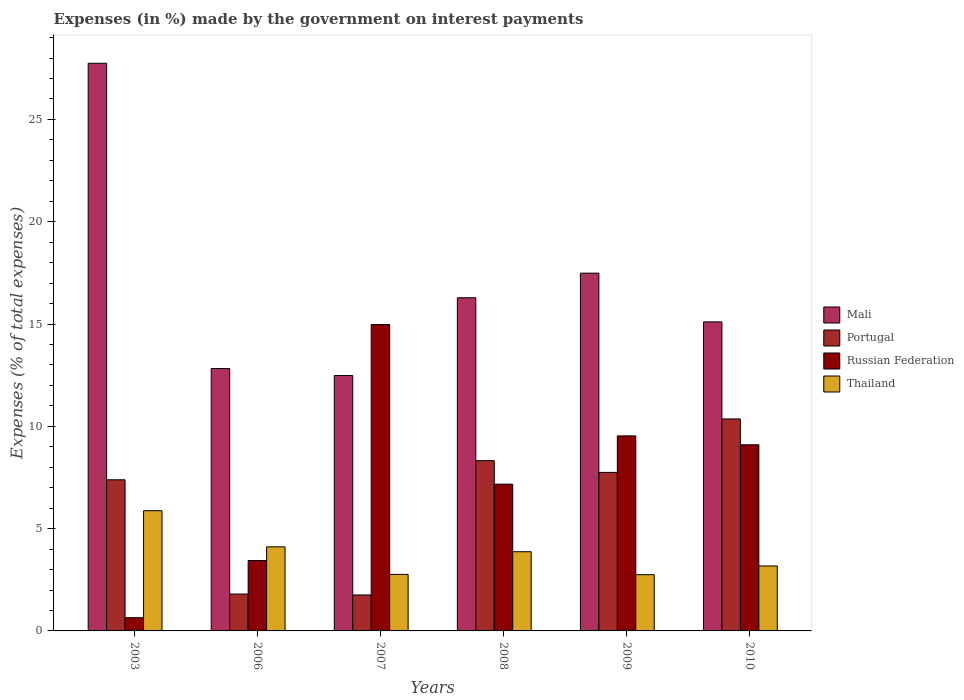How many different coloured bars are there?
Your answer should be compact. 4. How many groups of bars are there?
Your answer should be very brief. 6. Are the number of bars per tick equal to the number of legend labels?
Ensure brevity in your answer.  Yes. Are the number of bars on each tick of the X-axis equal?
Your response must be concise. Yes. How many bars are there on the 4th tick from the left?
Provide a succinct answer. 4. In how many cases, is the number of bars for a given year not equal to the number of legend labels?
Offer a terse response. 0. What is the percentage of expenses made by the government on interest payments in Mali in 2010?
Provide a short and direct response. 15.11. Across all years, what is the maximum percentage of expenses made by the government on interest payments in Thailand?
Make the answer very short. 5.88. Across all years, what is the minimum percentage of expenses made by the government on interest payments in Thailand?
Your answer should be very brief. 2.75. In which year was the percentage of expenses made by the government on interest payments in Portugal maximum?
Provide a short and direct response. 2010. In which year was the percentage of expenses made by the government on interest payments in Portugal minimum?
Offer a very short reply. 2007. What is the total percentage of expenses made by the government on interest payments in Thailand in the graph?
Your answer should be very brief. 22.54. What is the difference between the percentage of expenses made by the government on interest payments in Mali in 2008 and that in 2009?
Give a very brief answer. -1.2. What is the difference between the percentage of expenses made by the government on interest payments in Russian Federation in 2007 and the percentage of expenses made by the government on interest payments in Portugal in 2006?
Make the answer very short. 13.17. What is the average percentage of expenses made by the government on interest payments in Portugal per year?
Provide a short and direct response. 6.23. In the year 2003, what is the difference between the percentage of expenses made by the government on interest payments in Thailand and percentage of expenses made by the government on interest payments in Portugal?
Offer a terse response. -1.51. In how many years, is the percentage of expenses made by the government on interest payments in Mali greater than 5 %?
Make the answer very short. 6. What is the ratio of the percentage of expenses made by the government on interest payments in Thailand in 2006 to that in 2009?
Make the answer very short. 1.5. What is the difference between the highest and the second highest percentage of expenses made by the government on interest payments in Mali?
Your answer should be very brief. 10.26. What is the difference between the highest and the lowest percentage of expenses made by the government on interest payments in Thailand?
Offer a terse response. 3.13. In how many years, is the percentage of expenses made by the government on interest payments in Russian Federation greater than the average percentage of expenses made by the government on interest payments in Russian Federation taken over all years?
Offer a terse response. 3. Is the sum of the percentage of expenses made by the government on interest payments in Thailand in 2007 and 2010 greater than the maximum percentage of expenses made by the government on interest payments in Mali across all years?
Offer a terse response. No. What does the 4th bar from the left in 2007 represents?
Your answer should be very brief. Thailand. What does the 2nd bar from the right in 2008 represents?
Your answer should be very brief. Russian Federation. Is it the case that in every year, the sum of the percentage of expenses made by the government on interest payments in Portugal and percentage of expenses made by the government on interest payments in Thailand is greater than the percentage of expenses made by the government on interest payments in Russian Federation?
Keep it short and to the point. No. How many bars are there?
Offer a terse response. 24. Are all the bars in the graph horizontal?
Your answer should be very brief. No. How many years are there in the graph?
Give a very brief answer. 6. What is the difference between two consecutive major ticks on the Y-axis?
Offer a terse response. 5. Does the graph contain any zero values?
Your answer should be very brief. No. How are the legend labels stacked?
Offer a terse response. Vertical. What is the title of the graph?
Offer a very short reply. Expenses (in %) made by the government on interest payments. Does "Uzbekistan" appear as one of the legend labels in the graph?
Your answer should be compact. No. What is the label or title of the X-axis?
Provide a succinct answer. Years. What is the label or title of the Y-axis?
Ensure brevity in your answer.  Expenses (% of total expenses). What is the Expenses (% of total expenses) of Mali in 2003?
Your response must be concise. 27.75. What is the Expenses (% of total expenses) in Portugal in 2003?
Offer a terse response. 7.39. What is the Expenses (% of total expenses) in Russian Federation in 2003?
Provide a succinct answer. 0.65. What is the Expenses (% of total expenses) of Thailand in 2003?
Offer a terse response. 5.88. What is the Expenses (% of total expenses) in Mali in 2006?
Your answer should be very brief. 12.82. What is the Expenses (% of total expenses) in Portugal in 2006?
Offer a very short reply. 1.8. What is the Expenses (% of total expenses) of Russian Federation in 2006?
Offer a terse response. 3.44. What is the Expenses (% of total expenses) in Thailand in 2006?
Keep it short and to the point. 4.11. What is the Expenses (% of total expenses) in Mali in 2007?
Provide a short and direct response. 12.49. What is the Expenses (% of total expenses) of Portugal in 2007?
Make the answer very short. 1.76. What is the Expenses (% of total expenses) of Russian Federation in 2007?
Offer a terse response. 14.98. What is the Expenses (% of total expenses) of Thailand in 2007?
Your answer should be compact. 2.76. What is the Expenses (% of total expenses) of Mali in 2008?
Offer a terse response. 16.28. What is the Expenses (% of total expenses) in Portugal in 2008?
Offer a terse response. 8.32. What is the Expenses (% of total expenses) in Russian Federation in 2008?
Give a very brief answer. 7.17. What is the Expenses (% of total expenses) in Thailand in 2008?
Your response must be concise. 3.87. What is the Expenses (% of total expenses) in Mali in 2009?
Give a very brief answer. 17.49. What is the Expenses (% of total expenses) in Portugal in 2009?
Your answer should be compact. 7.75. What is the Expenses (% of total expenses) in Russian Federation in 2009?
Keep it short and to the point. 9.53. What is the Expenses (% of total expenses) of Thailand in 2009?
Keep it short and to the point. 2.75. What is the Expenses (% of total expenses) in Mali in 2010?
Keep it short and to the point. 15.11. What is the Expenses (% of total expenses) in Portugal in 2010?
Offer a terse response. 10.36. What is the Expenses (% of total expenses) of Russian Federation in 2010?
Keep it short and to the point. 9.1. What is the Expenses (% of total expenses) in Thailand in 2010?
Offer a terse response. 3.18. Across all years, what is the maximum Expenses (% of total expenses) in Mali?
Ensure brevity in your answer.  27.75. Across all years, what is the maximum Expenses (% of total expenses) of Portugal?
Keep it short and to the point. 10.36. Across all years, what is the maximum Expenses (% of total expenses) of Russian Federation?
Offer a very short reply. 14.98. Across all years, what is the maximum Expenses (% of total expenses) in Thailand?
Keep it short and to the point. 5.88. Across all years, what is the minimum Expenses (% of total expenses) of Mali?
Keep it short and to the point. 12.49. Across all years, what is the minimum Expenses (% of total expenses) in Portugal?
Your response must be concise. 1.76. Across all years, what is the minimum Expenses (% of total expenses) of Russian Federation?
Your answer should be compact. 0.65. Across all years, what is the minimum Expenses (% of total expenses) of Thailand?
Keep it short and to the point. 2.75. What is the total Expenses (% of total expenses) in Mali in the graph?
Make the answer very short. 101.93. What is the total Expenses (% of total expenses) in Portugal in the graph?
Provide a short and direct response. 37.38. What is the total Expenses (% of total expenses) in Russian Federation in the graph?
Offer a terse response. 44.86. What is the total Expenses (% of total expenses) of Thailand in the graph?
Ensure brevity in your answer.  22.54. What is the difference between the Expenses (% of total expenses) in Mali in 2003 and that in 2006?
Provide a short and direct response. 14.92. What is the difference between the Expenses (% of total expenses) in Portugal in 2003 and that in 2006?
Make the answer very short. 5.58. What is the difference between the Expenses (% of total expenses) in Russian Federation in 2003 and that in 2006?
Your answer should be compact. -2.8. What is the difference between the Expenses (% of total expenses) of Thailand in 2003 and that in 2006?
Your answer should be very brief. 1.77. What is the difference between the Expenses (% of total expenses) of Mali in 2003 and that in 2007?
Your answer should be very brief. 15.26. What is the difference between the Expenses (% of total expenses) in Portugal in 2003 and that in 2007?
Ensure brevity in your answer.  5.63. What is the difference between the Expenses (% of total expenses) in Russian Federation in 2003 and that in 2007?
Keep it short and to the point. -14.33. What is the difference between the Expenses (% of total expenses) in Thailand in 2003 and that in 2007?
Your answer should be very brief. 3.11. What is the difference between the Expenses (% of total expenses) in Mali in 2003 and that in 2008?
Offer a very short reply. 11.46. What is the difference between the Expenses (% of total expenses) of Portugal in 2003 and that in 2008?
Your answer should be very brief. -0.93. What is the difference between the Expenses (% of total expenses) of Russian Federation in 2003 and that in 2008?
Offer a terse response. -6.53. What is the difference between the Expenses (% of total expenses) in Thailand in 2003 and that in 2008?
Offer a very short reply. 2. What is the difference between the Expenses (% of total expenses) in Mali in 2003 and that in 2009?
Your answer should be very brief. 10.26. What is the difference between the Expenses (% of total expenses) of Portugal in 2003 and that in 2009?
Provide a succinct answer. -0.36. What is the difference between the Expenses (% of total expenses) of Russian Federation in 2003 and that in 2009?
Your answer should be very brief. -8.89. What is the difference between the Expenses (% of total expenses) in Thailand in 2003 and that in 2009?
Ensure brevity in your answer.  3.13. What is the difference between the Expenses (% of total expenses) of Mali in 2003 and that in 2010?
Your response must be concise. 12.64. What is the difference between the Expenses (% of total expenses) in Portugal in 2003 and that in 2010?
Provide a succinct answer. -2.97. What is the difference between the Expenses (% of total expenses) in Russian Federation in 2003 and that in 2010?
Your answer should be compact. -8.45. What is the difference between the Expenses (% of total expenses) in Thailand in 2003 and that in 2010?
Provide a succinct answer. 2.7. What is the difference between the Expenses (% of total expenses) in Mali in 2006 and that in 2007?
Your answer should be compact. 0.34. What is the difference between the Expenses (% of total expenses) in Portugal in 2006 and that in 2007?
Ensure brevity in your answer.  0.04. What is the difference between the Expenses (% of total expenses) of Russian Federation in 2006 and that in 2007?
Ensure brevity in your answer.  -11.54. What is the difference between the Expenses (% of total expenses) in Thailand in 2006 and that in 2007?
Provide a succinct answer. 1.35. What is the difference between the Expenses (% of total expenses) of Mali in 2006 and that in 2008?
Offer a terse response. -3.46. What is the difference between the Expenses (% of total expenses) in Portugal in 2006 and that in 2008?
Your answer should be very brief. -6.52. What is the difference between the Expenses (% of total expenses) of Russian Federation in 2006 and that in 2008?
Keep it short and to the point. -3.73. What is the difference between the Expenses (% of total expenses) in Thailand in 2006 and that in 2008?
Your answer should be very brief. 0.24. What is the difference between the Expenses (% of total expenses) in Mali in 2006 and that in 2009?
Provide a succinct answer. -4.66. What is the difference between the Expenses (% of total expenses) in Portugal in 2006 and that in 2009?
Offer a very short reply. -5.95. What is the difference between the Expenses (% of total expenses) in Russian Federation in 2006 and that in 2009?
Make the answer very short. -6.09. What is the difference between the Expenses (% of total expenses) of Thailand in 2006 and that in 2009?
Offer a very short reply. 1.36. What is the difference between the Expenses (% of total expenses) of Mali in 2006 and that in 2010?
Give a very brief answer. -2.28. What is the difference between the Expenses (% of total expenses) in Portugal in 2006 and that in 2010?
Offer a terse response. -8.56. What is the difference between the Expenses (% of total expenses) of Russian Federation in 2006 and that in 2010?
Give a very brief answer. -5.66. What is the difference between the Expenses (% of total expenses) in Thailand in 2006 and that in 2010?
Your answer should be compact. 0.93. What is the difference between the Expenses (% of total expenses) in Mali in 2007 and that in 2008?
Provide a succinct answer. -3.8. What is the difference between the Expenses (% of total expenses) in Portugal in 2007 and that in 2008?
Keep it short and to the point. -6.56. What is the difference between the Expenses (% of total expenses) of Russian Federation in 2007 and that in 2008?
Your answer should be very brief. 7.8. What is the difference between the Expenses (% of total expenses) of Thailand in 2007 and that in 2008?
Provide a short and direct response. -1.11. What is the difference between the Expenses (% of total expenses) of Mali in 2007 and that in 2009?
Give a very brief answer. -5. What is the difference between the Expenses (% of total expenses) in Portugal in 2007 and that in 2009?
Provide a succinct answer. -5.99. What is the difference between the Expenses (% of total expenses) in Russian Federation in 2007 and that in 2009?
Your response must be concise. 5.44. What is the difference between the Expenses (% of total expenses) in Thailand in 2007 and that in 2009?
Your response must be concise. 0.01. What is the difference between the Expenses (% of total expenses) of Mali in 2007 and that in 2010?
Offer a very short reply. -2.62. What is the difference between the Expenses (% of total expenses) in Portugal in 2007 and that in 2010?
Your answer should be very brief. -8.6. What is the difference between the Expenses (% of total expenses) in Russian Federation in 2007 and that in 2010?
Make the answer very short. 5.88. What is the difference between the Expenses (% of total expenses) in Thailand in 2007 and that in 2010?
Ensure brevity in your answer.  -0.41. What is the difference between the Expenses (% of total expenses) in Mali in 2008 and that in 2009?
Offer a very short reply. -1.2. What is the difference between the Expenses (% of total expenses) of Portugal in 2008 and that in 2009?
Provide a succinct answer. 0.57. What is the difference between the Expenses (% of total expenses) in Russian Federation in 2008 and that in 2009?
Offer a very short reply. -2.36. What is the difference between the Expenses (% of total expenses) of Thailand in 2008 and that in 2009?
Offer a very short reply. 1.12. What is the difference between the Expenses (% of total expenses) in Mali in 2008 and that in 2010?
Your answer should be very brief. 1.18. What is the difference between the Expenses (% of total expenses) of Portugal in 2008 and that in 2010?
Give a very brief answer. -2.04. What is the difference between the Expenses (% of total expenses) of Russian Federation in 2008 and that in 2010?
Provide a short and direct response. -1.93. What is the difference between the Expenses (% of total expenses) of Thailand in 2008 and that in 2010?
Your answer should be compact. 0.7. What is the difference between the Expenses (% of total expenses) of Mali in 2009 and that in 2010?
Give a very brief answer. 2.38. What is the difference between the Expenses (% of total expenses) of Portugal in 2009 and that in 2010?
Provide a succinct answer. -2.61. What is the difference between the Expenses (% of total expenses) of Russian Federation in 2009 and that in 2010?
Provide a short and direct response. 0.43. What is the difference between the Expenses (% of total expenses) in Thailand in 2009 and that in 2010?
Provide a short and direct response. -0.43. What is the difference between the Expenses (% of total expenses) in Mali in 2003 and the Expenses (% of total expenses) in Portugal in 2006?
Provide a short and direct response. 25.94. What is the difference between the Expenses (% of total expenses) of Mali in 2003 and the Expenses (% of total expenses) of Russian Federation in 2006?
Keep it short and to the point. 24.3. What is the difference between the Expenses (% of total expenses) of Mali in 2003 and the Expenses (% of total expenses) of Thailand in 2006?
Your response must be concise. 23.64. What is the difference between the Expenses (% of total expenses) in Portugal in 2003 and the Expenses (% of total expenses) in Russian Federation in 2006?
Offer a terse response. 3.95. What is the difference between the Expenses (% of total expenses) of Portugal in 2003 and the Expenses (% of total expenses) of Thailand in 2006?
Give a very brief answer. 3.28. What is the difference between the Expenses (% of total expenses) in Russian Federation in 2003 and the Expenses (% of total expenses) in Thailand in 2006?
Offer a terse response. -3.46. What is the difference between the Expenses (% of total expenses) of Mali in 2003 and the Expenses (% of total expenses) of Portugal in 2007?
Provide a succinct answer. 25.99. What is the difference between the Expenses (% of total expenses) in Mali in 2003 and the Expenses (% of total expenses) in Russian Federation in 2007?
Your answer should be very brief. 12.77. What is the difference between the Expenses (% of total expenses) of Mali in 2003 and the Expenses (% of total expenses) of Thailand in 2007?
Offer a terse response. 24.98. What is the difference between the Expenses (% of total expenses) in Portugal in 2003 and the Expenses (% of total expenses) in Russian Federation in 2007?
Make the answer very short. -7.59. What is the difference between the Expenses (% of total expenses) of Portugal in 2003 and the Expenses (% of total expenses) of Thailand in 2007?
Your answer should be very brief. 4.62. What is the difference between the Expenses (% of total expenses) of Russian Federation in 2003 and the Expenses (% of total expenses) of Thailand in 2007?
Keep it short and to the point. -2.12. What is the difference between the Expenses (% of total expenses) in Mali in 2003 and the Expenses (% of total expenses) in Portugal in 2008?
Your answer should be very brief. 19.42. What is the difference between the Expenses (% of total expenses) of Mali in 2003 and the Expenses (% of total expenses) of Russian Federation in 2008?
Give a very brief answer. 20.57. What is the difference between the Expenses (% of total expenses) of Mali in 2003 and the Expenses (% of total expenses) of Thailand in 2008?
Offer a terse response. 23.87. What is the difference between the Expenses (% of total expenses) in Portugal in 2003 and the Expenses (% of total expenses) in Russian Federation in 2008?
Offer a very short reply. 0.21. What is the difference between the Expenses (% of total expenses) of Portugal in 2003 and the Expenses (% of total expenses) of Thailand in 2008?
Offer a terse response. 3.52. What is the difference between the Expenses (% of total expenses) of Russian Federation in 2003 and the Expenses (% of total expenses) of Thailand in 2008?
Make the answer very short. -3.23. What is the difference between the Expenses (% of total expenses) in Mali in 2003 and the Expenses (% of total expenses) in Portugal in 2009?
Provide a short and direct response. 20. What is the difference between the Expenses (% of total expenses) of Mali in 2003 and the Expenses (% of total expenses) of Russian Federation in 2009?
Make the answer very short. 18.21. What is the difference between the Expenses (% of total expenses) of Mali in 2003 and the Expenses (% of total expenses) of Thailand in 2009?
Your response must be concise. 25. What is the difference between the Expenses (% of total expenses) in Portugal in 2003 and the Expenses (% of total expenses) in Russian Federation in 2009?
Offer a terse response. -2.15. What is the difference between the Expenses (% of total expenses) of Portugal in 2003 and the Expenses (% of total expenses) of Thailand in 2009?
Give a very brief answer. 4.64. What is the difference between the Expenses (% of total expenses) in Russian Federation in 2003 and the Expenses (% of total expenses) in Thailand in 2009?
Offer a terse response. -2.1. What is the difference between the Expenses (% of total expenses) of Mali in 2003 and the Expenses (% of total expenses) of Portugal in 2010?
Make the answer very short. 17.38. What is the difference between the Expenses (% of total expenses) in Mali in 2003 and the Expenses (% of total expenses) in Russian Federation in 2010?
Give a very brief answer. 18.65. What is the difference between the Expenses (% of total expenses) in Mali in 2003 and the Expenses (% of total expenses) in Thailand in 2010?
Your response must be concise. 24.57. What is the difference between the Expenses (% of total expenses) of Portugal in 2003 and the Expenses (% of total expenses) of Russian Federation in 2010?
Provide a short and direct response. -1.71. What is the difference between the Expenses (% of total expenses) in Portugal in 2003 and the Expenses (% of total expenses) in Thailand in 2010?
Your response must be concise. 4.21. What is the difference between the Expenses (% of total expenses) in Russian Federation in 2003 and the Expenses (% of total expenses) in Thailand in 2010?
Keep it short and to the point. -2.53. What is the difference between the Expenses (% of total expenses) of Mali in 2006 and the Expenses (% of total expenses) of Portugal in 2007?
Offer a terse response. 11.07. What is the difference between the Expenses (% of total expenses) of Mali in 2006 and the Expenses (% of total expenses) of Russian Federation in 2007?
Your answer should be compact. -2.15. What is the difference between the Expenses (% of total expenses) of Mali in 2006 and the Expenses (% of total expenses) of Thailand in 2007?
Give a very brief answer. 10.06. What is the difference between the Expenses (% of total expenses) in Portugal in 2006 and the Expenses (% of total expenses) in Russian Federation in 2007?
Give a very brief answer. -13.17. What is the difference between the Expenses (% of total expenses) in Portugal in 2006 and the Expenses (% of total expenses) in Thailand in 2007?
Your answer should be very brief. -0.96. What is the difference between the Expenses (% of total expenses) of Russian Federation in 2006 and the Expenses (% of total expenses) of Thailand in 2007?
Your answer should be compact. 0.68. What is the difference between the Expenses (% of total expenses) of Mali in 2006 and the Expenses (% of total expenses) of Portugal in 2008?
Offer a very short reply. 4.5. What is the difference between the Expenses (% of total expenses) in Mali in 2006 and the Expenses (% of total expenses) in Russian Federation in 2008?
Give a very brief answer. 5.65. What is the difference between the Expenses (% of total expenses) of Mali in 2006 and the Expenses (% of total expenses) of Thailand in 2008?
Give a very brief answer. 8.95. What is the difference between the Expenses (% of total expenses) of Portugal in 2006 and the Expenses (% of total expenses) of Russian Federation in 2008?
Offer a very short reply. -5.37. What is the difference between the Expenses (% of total expenses) of Portugal in 2006 and the Expenses (% of total expenses) of Thailand in 2008?
Your answer should be very brief. -2.07. What is the difference between the Expenses (% of total expenses) of Russian Federation in 2006 and the Expenses (% of total expenses) of Thailand in 2008?
Your answer should be very brief. -0.43. What is the difference between the Expenses (% of total expenses) of Mali in 2006 and the Expenses (% of total expenses) of Portugal in 2009?
Your answer should be very brief. 5.08. What is the difference between the Expenses (% of total expenses) in Mali in 2006 and the Expenses (% of total expenses) in Russian Federation in 2009?
Provide a short and direct response. 3.29. What is the difference between the Expenses (% of total expenses) of Mali in 2006 and the Expenses (% of total expenses) of Thailand in 2009?
Ensure brevity in your answer.  10.08. What is the difference between the Expenses (% of total expenses) in Portugal in 2006 and the Expenses (% of total expenses) in Russian Federation in 2009?
Keep it short and to the point. -7.73. What is the difference between the Expenses (% of total expenses) in Portugal in 2006 and the Expenses (% of total expenses) in Thailand in 2009?
Your answer should be very brief. -0.95. What is the difference between the Expenses (% of total expenses) of Russian Federation in 2006 and the Expenses (% of total expenses) of Thailand in 2009?
Ensure brevity in your answer.  0.69. What is the difference between the Expenses (% of total expenses) in Mali in 2006 and the Expenses (% of total expenses) in Portugal in 2010?
Offer a terse response. 2.46. What is the difference between the Expenses (% of total expenses) of Mali in 2006 and the Expenses (% of total expenses) of Russian Federation in 2010?
Give a very brief answer. 3.73. What is the difference between the Expenses (% of total expenses) in Mali in 2006 and the Expenses (% of total expenses) in Thailand in 2010?
Provide a short and direct response. 9.65. What is the difference between the Expenses (% of total expenses) in Portugal in 2006 and the Expenses (% of total expenses) in Russian Federation in 2010?
Provide a short and direct response. -7.3. What is the difference between the Expenses (% of total expenses) of Portugal in 2006 and the Expenses (% of total expenses) of Thailand in 2010?
Give a very brief answer. -1.37. What is the difference between the Expenses (% of total expenses) in Russian Federation in 2006 and the Expenses (% of total expenses) in Thailand in 2010?
Give a very brief answer. 0.27. What is the difference between the Expenses (% of total expenses) in Mali in 2007 and the Expenses (% of total expenses) in Portugal in 2008?
Your answer should be compact. 4.16. What is the difference between the Expenses (% of total expenses) of Mali in 2007 and the Expenses (% of total expenses) of Russian Federation in 2008?
Keep it short and to the point. 5.31. What is the difference between the Expenses (% of total expenses) of Mali in 2007 and the Expenses (% of total expenses) of Thailand in 2008?
Offer a terse response. 8.61. What is the difference between the Expenses (% of total expenses) in Portugal in 2007 and the Expenses (% of total expenses) in Russian Federation in 2008?
Provide a succinct answer. -5.41. What is the difference between the Expenses (% of total expenses) in Portugal in 2007 and the Expenses (% of total expenses) in Thailand in 2008?
Offer a terse response. -2.11. What is the difference between the Expenses (% of total expenses) of Russian Federation in 2007 and the Expenses (% of total expenses) of Thailand in 2008?
Provide a short and direct response. 11.1. What is the difference between the Expenses (% of total expenses) of Mali in 2007 and the Expenses (% of total expenses) of Portugal in 2009?
Offer a very short reply. 4.74. What is the difference between the Expenses (% of total expenses) of Mali in 2007 and the Expenses (% of total expenses) of Russian Federation in 2009?
Provide a short and direct response. 2.95. What is the difference between the Expenses (% of total expenses) in Mali in 2007 and the Expenses (% of total expenses) in Thailand in 2009?
Your answer should be very brief. 9.74. What is the difference between the Expenses (% of total expenses) in Portugal in 2007 and the Expenses (% of total expenses) in Russian Federation in 2009?
Give a very brief answer. -7.77. What is the difference between the Expenses (% of total expenses) of Portugal in 2007 and the Expenses (% of total expenses) of Thailand in 2009?
Offer a terse response. -0.99. What is the difference between the Expenses (% of total expenses) in Russian Federation in 2007 and the Expenses (% of total expenses) in Thailand in 2009?
Offer a very short reply. 12.23. What is the difference between the Expenses (% of total expenses) of Mali in 2007 and the Expenses (% of total expenses) of Portugal in 2010?
Keep it short and to the point. 2.12. What is the difference between the Expenses (% of total expenses) in Mali in 2007 and the Expenses (% of total expenses) in Russian Federation in 2010?
Make the answer very short. 3.39. What is the difference between the Expenses (% of total expenses) in Mali in 2007 and the Expenses (% of total expenses) in Thailand in 2010?
Your answer should be very brief. 9.31. What is the difference between the Expenses (% of total expenses) in Portugal in 2007 and the Expenses (% of total expenses) in Russian Federation in 2010?
Keep it short and to the point. -7.34. What is the difference between the Expenses (% of total expenses) of Portugal in 2007 and the Expenses (% of total expenses) of Thailand in 2010?
Provide a short and direct response. -1.42. What is the difference between the Expenses (% of total expenses) of Russian Federation in 2007 and the Expenses (% of total expenses) of Thailand in 2010?
Offer a terse response. 11.8. What is the difference between the Expenses (% of total expenses) of Mali in 2008 and the Expenses (% of total expenses) of Portugal in 2009?
Provide a short and direct response. 8.54. What is the difference between the Expenses (% of total expenses) in Mali in 2008 and the Expenses (% of total expenses) in Russian Federation in 2009?
Provide a succinct answer. 6.75. What is the difference between the Expenses (% of total expenses) in Mali in 2008 and the Expenses (% of total expenses) in Thailand in 2009?
Your response must be concise. 13.54. What is the difference between the Expenses (% of total expenses) of Portugal in 2008 and the Expenses (% of total expenses) of Russian Federation in 2009?
Keep it short and to the point. -1.21. What is the difference between the Expenses (% of total expenses) of Portugal in 2008 and the Expenses (% of total expenses) of Thailand in 2009?
Offer a terse response. 5.57. What is the difference between the Expenses (% of total expenses) of Russian Federation in 2008 and the Expenses (% of total expenses) of Thailand in 2009?
Ensure brevity in your answer.  4.42. What is the difference between the Expenses (% of total expenses) in Mali in 2008 and the Expenses (% of total expenses) in Portugal in 2010?
Your answer should be very brief. 5.92. What is the difference between the Expenses (% of total expenses) in Mali in 2008 and the Expenses (% of total expenses) in Russian Federation in 2010?
Provide a short and direct response. 7.19. What is the difference between the Expenses (% of total expenses) in Mali in 2008 and the Expenses (% of total expenses) in Thailand in 2010?
Your answer should be very brief. 13.11. What is the difference between the Expenses (% of total expenses) of Portugal in 2008 and the Expenses (% of total expenses) of Russian Federation in 2010?
Provide a succinct answer. -0.78. What is the difference between the Expenses (% of total expenses) in Portugal in 2008 and the Expenses (% of total expenses) in Thailand in 2010?
Your answer should be compact. 5.15. What is the difference between the Expenses (% of total expenses) in Russian Federation in 2008 and the Expenses (% of total expenses) in Thailand in 2010?
Your response must be concise. 4. What is the difference between the Expenses (% of total expenses) of Mali in 2009 and the Expenses (% of total expenses) of Portugal in 2010?
Your answer should be compact. 7.12. What is the difference between the Expenses (% of total expenses) in Mali in 2009 and the Expenses (% of total expenses) in Russian Federation in 2010?
Your response must be concise. 8.39. What is the difference between the Expenses (% of total expenses) in Mali in 2009 and the Expenses (% of total expenses) in Thailand in 2010?
Make the answer very short. 14.31. What is the difference between the Expenses (% of total expenses) of Portugal in 2009 and the Expenses (% of total expenses) of Russian Federation in 2010?
Provide a short and direct response. -1.35. What is the difference between the Expenses (% of total expenses) of Portugal in 2009 and the Expenses (% of total expenses) of Thailand in 2010?
Give a very brief answer. 4.57. What is the difference between the Expenses (% of total expenses) of Russian Federation in 2009 and the Expenses (% of total expenses) of Thailand in 2010?
Your answer should be compact. 6.36. What is the average Expenses (% of total expenses) of Mali per year?
Provide a succinct answer. 16.99. What is the average Expenses (% of total expenses) in Portugal per year?
Provide a succinct answer. 6.23. What is the average Expenses (% of total expenses) in Russian Federation per year?
Your response must be concise. 7.48. What is the average Expenses (% of total expenses) of Thailand per year?
Offer a terse response. 3.76. In the year 2003, what is the difference between the Expenses (% of total expenses) in Mali and Expenses (% of total expenses) in Portugal?
Your answer should be compact. 20.36. In the year 2003, what is the difference between the Expenses (% of total expenses) in Mali and Expenses (% of total expenses) in Russian Federation?
Provide a short and direct response. 27.1. In the year 2003, what is the difference between the Expenses (% of total expenses) of Mali and Expenses (% of total expenses) of Thailand?
Your answer should be compact. 21.87. In the year 2003, what is the difference between the Expenses (% of total expenses) of Portugal and Expenses (% of total expenses) of Russian Federation?
Ensure brevity in your answer.  6.74. In the year 2003, what is the difference between the Expenses (% of total expenses) in Portugal and Expenses (% of total expenses) in Thailand?
Your answer should be compact. 1.51. In the year 2003, what is the difference between the Expenses (% of total expenses) of Russian Federation and Expenses (% of total expenses) of Thailand?
Offer a terse response. -5.23. In the year 2006, what is the difference between the Expenses (% of total expenses) of Mali and Expenses (% of total expenses) of Portugal?
Provide a short and direct response. 11.02. In the year 2006, what is the difference between the Expenses (% of total expenses) of Mali and Expenses (% of total expenses) of Russian Federation?
Offer a very short reply. 9.38. In the year 2006, what is the difference between the Expenses (% of total expenses) of Mali and Expenses (% of total expenses) of Thailand?
Your answer should be compact. 8.71. In the year 2006, what is the difference between the Expenses (% of total expenses) of Portugal and Expenses (% of total expenses) of Russian Federation?
Provide a succinct answer. -1.64. In the year 2006, what is the difference between the Expenses (% of total expenses) of Portugal and Expenses (% of total expenses) of Thailand?
Your answer should be compact. -2.31. In the year 2006, what is the difference between the Expenses (% of total expenses) of Russian Federation and Expenses (% of total expenses) of Thailand?
Keep it short and to the point. -0.67. In the year 2007, what is the difference between the Expenses (% of total expenses) of Mali and Expenses (% of total expenses) of Portugal?
Your answer should be very brief. 10.73. In the year 2007, what is the difference between the Expenses (% of total expenses) in Mali and Expenses (% of total expenses) in Russian Federation?
Keep it short and to the point. -2.49. In the year 2007, what is the difference between the Expenses (% of total expenses) in Mali and Expenses (% of total expenses) in Thailand?
Offer a very short reply. 9.72. In the year 2007, what is the difference between the Expenses (% of total expenses) of Portugal and Expenses (% of total expenses) of Russian Federation?
Your response must be concise. -13.22. In the year 2007, what is the difference between the Expenses (% of total expenses) in Portugal and Expenses (% of total expenses) in Thailand?
Ensure brevity in your answer.  -1. In the year 2007, what is the difference between the Expenses (% of total expenses) of Russian Federation and Expenses (% of total expenses) of Thailand?
Provide a short and direct response. 12.21. In the year 2008, what is the difference between the Expenses (% of total expenses) in Mali and Expenses (% of total expenses) in Portugal?
Offer a terse response. 7.96. In the year 2008, what is the difference between the Expenses (% of total expenses) in Mali and Expenses (% of total expenses) in Russian Federation?
Provide a succinct answer. 9.11. In the year 2008, what is the difference between the Expenses (% of total expenses) of Mali and Expenses (% of total expenses) of Thailand?
Provide a short and direct response. 12.41. In the year 2008, what is the difference between the Expenses (% of total expenses) in Portugal and Expenses (% of total expenses) in Russian Federation?
Ensure brevity in your answer.  1.15. In the year 2008, what is the difference between the Expenses (% of total expenses) of Portugal and Expenses (% of total expenses) of Thailand?
Provide a succinct answer. 4.45. In the year 2008, what is the difference between the Expenses (% of total expenses) of Russian Federation and Expenses (% of total expenses) of Thailand?
Give a very brief answer. 3.3. In the year 2009, what is the difference between the Expenses (% of total expenses) of Mali and Expenses (% of total expenses) of Portugal?
Make the answer very short. 9.74. In the year 2009, what is the difference between the Expenses (% of total expenses) in Mali and Expenses (% of total expenses) in Russian Federation?
Your answer should be compact. 7.95. In the year 2009, what is the difference between the Expenses (% of total expenses) in Mali and Expenses (% of total expenses) in Thailand?
Offer a very short reply. 14.74. In the year 2009, what is the difference between the Expenses (% of total expenses) of Portugal and Expenses (% of total expenses) of Russian Federation?
Your answer should be compact. -1.78. In the year 2009, what is the difference between the Expenses (% of total expenses) of Portugal and Expenses (% of total expenses) of Thailand?
Provide a succinct answer. 5. In the year 2009, what is the difference between the Expenses (% of total expenses) of Russian Federation and Expenses (% of total expenses) of Thailand?
Your response must be concise. 6.78. In the year 2010, what is the difference between the Expenses (% of total expenses) in Mali and Expenses (% of total expenses) in Portugal?
Give a very brief answer. 4.74. In the year 2010, what is the difference between the Expenses (% of total expenses) of Mali and Expenses (% of total expenses) of Russian Federation?
Keep it short and to the point. 6.01. In the year 2010, what is the difference between the Expenses (% of total expenses) in Mali and Expenses (% of total expenses) in Thailand?
Provide a succinct answer. 11.93. In the year 2010, what is the difference between the Expenses (% of total expenses) in Portugal and Expenses (% of total expenses) in Russian Federation?
Give a very brief answer. 1.26. In the year 2010, what is the difference between the Expenses (% of total expenses) in Portugal and Expenses (% of total expenses) in Thailand?
Keep it short and to the point. 7.19. In the year 2010, what is the difference between the Expenses (% of total expenses) in Russian Federation and Expenses (% of total expenses) in Thailand?
Offer a terse response. 5.92. What is the ratio of the Expenses (% of total expenses) in Mali in 2003 to that in 2006?
Provide a short and direct response. 2.16. What is the ratio of the Expenses (% of total expenses) in Portugal in 2003 to that in 2006?
Your response must be concise. 4.1. What is the ratio of the Expenses (% of total expenses) of Russian Federation in 2003 to that in 2006?
Your answer should be compact. 0.19. What is the ratio of the Expenses (% of total expenses) in Thailand in 2003 to that in 2006?
Make the answer very short. 1.43. What is the ratio of the Expenses (% of total expenses) in Mali in 2003 to that in 2007?
Keep it short and to the point. 2.22. What is the ratio of the Expenses (% of total expenses) of Portugal in 2003 to that in 2007?
Provide a short and direct response. 4.2. What is the ratio of the Expenses (% of total expenses) of Russian Federation in 2003 to that in 2007?
Your answer should be compact. 0.04. What is the ratio of the Expenses (% of total expenses) of Thailand in 2003 to that in 2007?
Your response must be concise. 2.13. What is the ratio of the Expenses (% of total expenses) in Mali in 2003 to that in 2008?
Provide a succinct answer. 1.7. What is the ratio of the Expenses (% of total expenses) in Portugal in 2003 to that in 2008?
Keep it short and to the point. 0.89. What is the ratio of the Expenses (% of total expenses) in Russian Federation in 2003 to that in 2008?
Your response must be concise. 0.09. What is the ratio of the Expenses (% of total expenses) in Thailand in 2003 to that in 2008?
Your answer should be compact. 1.52. What is the ratio of the Expenses (% of total expenses) in Mali in 2003 to that in 2009?
Make the answer very short. 1.59. What is the ratio of the Expenses (% of total expenses) of Portugal in 2003 to that in 2009?
Keep it short and to the point. 0.95. What is the ratio of the Expenses (% of total expenses) of Russian Federation in 2003 to that in 2009?
Give a very brief answer. 0.07. What is the ratio of the Expenses (% of total expenses) of Thailand in 2003 to that in 2009?
Keep it short and to the point. 2.14. What is the ratio of the Expenses (% of total expenses) in Mali in 2003 to that in 2010?
Keep it short and to the point. 1.84. What is the ratio of the Expenses (% of total expenses) in Portugal in 2003 to that in 2010?
Ensure brevity in your answer.  0.71. What is the ratio of the Expenses (% of total expenses) of Russian Federation in 2003 to that in 2010?
Your answer should be compact. 0.07. What is the ratio of the Expenses (% of total expenses) in Thailand in 2003 to that in 2010?
Ensure brevity in your answer.  1.85. What is the ratio of the Expenses (% of total expenses) of Mali in 2006 to that in 2007?
Offer a terse response. 1.03. What is the ratio of the Expenses (% of total expenses) of Portugal in 2006 to that in 2007?
Keep it short and to the point. 1.03. What is the ratio of the Expenses (% of total expenses) of Russian Federation in 2006 to that in 2007?
Offer a terse response. 0.23. What is the ratio of the Expenses (% of total expenses) in Thailand in 2006 to that in 2007?
Give a very brief answer. 1.49. What is the ratio of the Expenses (% of total expenses) of Mali in 2006 to that in 2008?
Your answer should be very brief. 0.79. What is the ratio of the Expenses (% of total expenses) in Portugal in 2006 to that in 2008?
Your answer should be very brief. 0.22. What is the ratio of the Expenses (% of total expenses) of Russian Federation in 2006 to that in 2008?
Your answer should be very brief. 0.48. What is the ratio of the Expenses (% of total expenses) in Thailand in 2006 to that in 2008?
Provide a succinct answer. 1.06. What is the ratio of the Expenses (% of total expenses) in Mali in 2006 to that in 2009?
Give a very brief answer. 0.73. What is the ratio of the Expenses (% of total expenses) of Portugal in 2006 to that in 2009?
Provide a succinct answer. 0.23. What is the ratio of the Expenses (% of total expenses) of Russian Federation in 2006 to that in 2009?
Give a very brief answer. 0.36. What is the ratio of the Expenses (% of total expenses) in Thailand in 2006 to that in 2009?
Your answer should be compact. 1.5. What is the ratio of the Expenses (% of total expenses) of Mali in 2006 to that in 2010?
Offer a terse response. 0.85. What is the ratio of the Expenses (% of total expenses) of Portugal in 2006 to that in 2010?
Make the answer very short. 0.17. What is the ratio of the Expenses (% of total expenses) of Russian Federation in 2006 to that in 2010?
Offer a very short reply. 0.38. What is the ratio of the Expenses (% of total expenses) in Thailand in 2006 to that in 2010?
Keep it short and to the point. 1.29. What is the ratio of the Expenses (% of total expenses) of Mali in 2007 to that in 2008?
Your answer should be compact. 0.77. What is the ratio of the Expenses (% of total expenses) in Portugal in 2007 to that in 2008?
Your response must be concise. 0.21. What is the ratio of the Expenses (% of total expenses) in Russian Federation in 2007 to that in 2008?
Give a very brief answer. 2.09. What is the ratio of the Expenses (% of total expenses) in Thailand in 2007 to that in 2008?
Your answer should be very brief. 0.71. What is the ratio of the Expenses (% of total expenses) of Mali in 2007 to that in 2009?
Your answer should be compact. 0.71. What is the ratio of the Expenses (% of total expenses) in Portugal in 2007 to that in 2009?
Offer a very short reply. 0.23. What is the ratio of the Expenses (% of total expenses) in Russian Federation in 2007 to that in 2009?
Offer a terse response. 1.57. What is the ratio of the Expenses (% of total expenses) in Mali in 2007 to that in 2010?
Give a very brief answer. 0.83. What is the ratio of the Expenses (% of total expenses) of Portugal in 2007 to that in 2010?
Ensure brevity in your answer.  0.17. What is the ratio of the Expenses (% of total expenses) in Russian Federation in 2007 to that in 2010?
Ensure brevity in your answer.  1.65. What is the ratio of the Expenses (% of total expenses) of Thailand in 2007 to that in 2010?
Your answer should be very brief. 0.87. What is the ratio of the Expenses (% of total expenses) of Mali in 2008 to that in 2009?
Offer a very short reply. 0.93. What is the ratio of the Expenses (% of total expenses) in Portugal in 2008 to that in 2009?
Offer a terse response. 1.07. What is the ratio of the Expenses (% of total expenses) in Russian Federation in 2008 to that in 2009?
Your answer should be very brief. 0.75. What is the ratio of the Expenses (% of total expenses) of Thailand in 2008 to that in 2009?
Your answer should be very brief. 1.41. What is the ratio of the Expenses (% of total expenses) in Mali in 2008 to that in 2010?
Your response must be concise. 1.08. What is the ratio of the Expenses (% of total expenses) of Portugal in 2008 to that in 2010?
Make the answer very short. 0.8. What is the ratio of the Expenses (% of total expenses) of Russian Federation in 2008 to that in 2010?
Offer a very short reply. 0.79. What is the ratio of the Expenses (% of total expenses) of Thailand in 2008 to that in 2010?
Keep it short and to the point. 1.22. What is the ratio of the Expenses (% of total expenses) of Mali in 2009 to that in 2010?
Offer a terse response. 1.16. What is the ratio of the Expenses (% of total expenses) of Portugal in 2009 to that in 2010?
Your answer should be compact. 0.75. What is the ratio of the Expenses (% of total expenses) in Russian Federation in 2009 to that in 2010?
Your answer should be very brief. 1.05. What is the ratio of the Expenses (% of total expenses) in Thailand in 2009 to that in 2010?
Give a very brief answer. 0.87. What is the difference between the highest and the second highest Expenses (% of total expenses) of Mali?
Keep it short and to the point. 10.26. What is the difference between the highest and the second highest Expenses (% of total expenses) of Portugal?
Your answer should be compact. 2.04. What is the difference between the highest and the second highest Expenses (% of total expenses) of Russian Federation?
Keep it short and to the point. 5.44. What is the difference between the highest and the second highest Expenses (% of total expenses) of Thailand?
Give a very brief answer. 1.77. What is the difference between the highest and the lowest Expenses (% of total expenses) in Mali?
Your response must be concise. 15.26. What is the difference between the highest and the lowest Expenses (% of total expenses) in Portugal?
Your answer should be compact. 8.6. What is the difference between the highest and the lowest Expenses (% of total expenses) in Russian Federation?
Offer a terse response. 14.33. What is the difference between the highest and the lowest Expenses (% of total expenses) in Thailand?
Your answer should be compact. 3.13. 